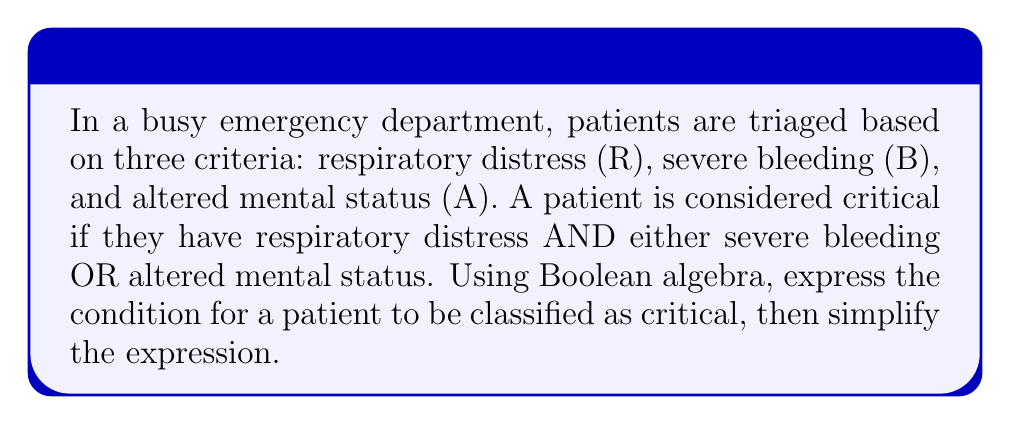Help me with this question. Let's approach this step-by-step:

1) First, we need to express the condition in Boolean algebra:
   Critical = R AND (B OR A)

2) This can be written as:
   $$C = R \cdot (B + A)$$

3) To simplify this, we can use the distributive law of Boolean algebra:
   $$C = R \cdot B + R \cdot A$$

4) This expression is already in its simplest form, known as the sum of products (SOP) form.

5) We can verify this using a truth table:

   | R | B | A | R·(B+A) | R·B + R·A |
   |---|---|---|---------|-----------|
   | 0 | 0 | 0 |    0    |     0     |
   | 0 | 0 | 1 |    0    |     0     |
   | 0 | 1 | 0 |    0    |     0     |
   | 0 | 1 | 1 |    0    |     0     |
   | 1 | 0 | 0 |    0    |     0     |
   | 1 | 0 | 1 |    1    |     1     |
   | 1 | 1 | 0 |    1    |     1     |
   | 1 | 1 | 1 |    1    |     1     |

6) The truth table confirms that both expressions are equivalent.

This simplified expression helps trauma nurses quickly assess if a patient is critical by checking for respiratory distress (R) and then either severe bleeding (B) or altered mental status (A).
Answer: $$C = R \cdot B + R \cdot A$$ 